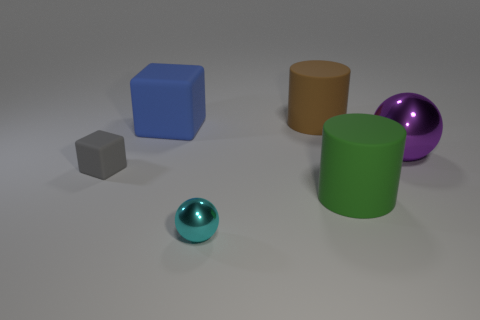Add 2 green rubber balls. How many objects exist? 8 Subtract all cylinders. How many objects are left? 4 Add 4 gray blocks. How many gray blocks exist? 5 Subtract 0 gray cylinders. How many objects are left? 6 Subtract all small cyan metallic cylinders. Subtract all tiny gray matte objects. How many objects are left? 5 Add 6 tiny objects. How many tiny objects are left? 8 